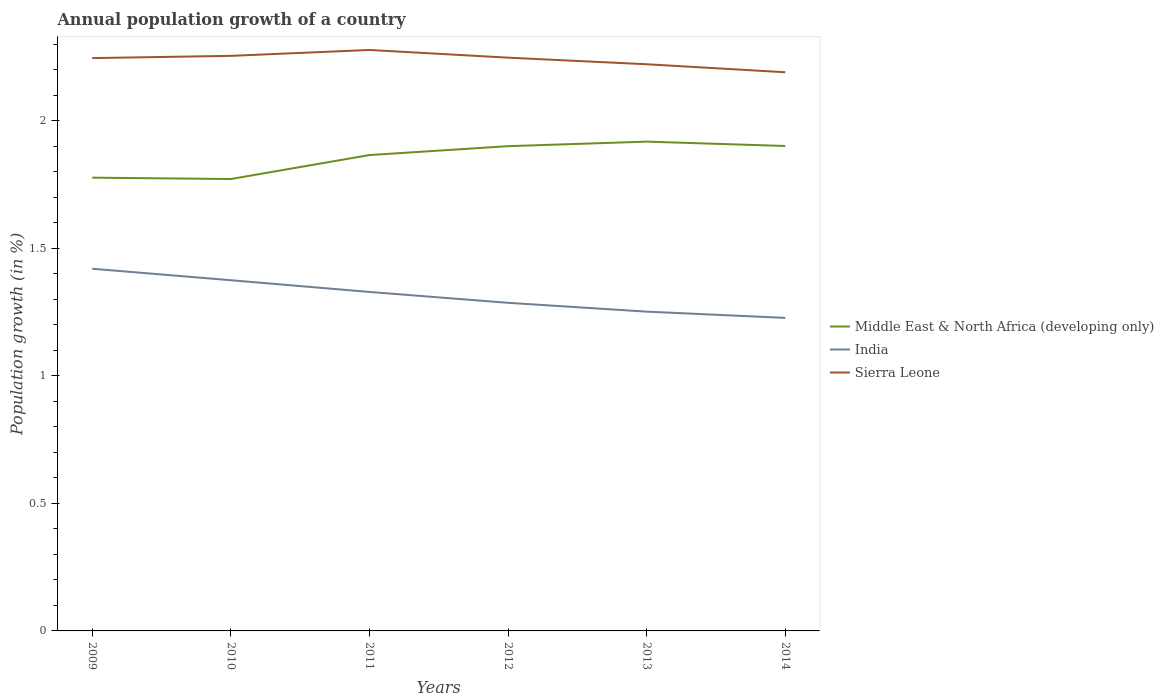Does the line corresponding to Sierra Leone intersect with the line corresponding to Middle East & North Africa (developing only)?
Offer a terse response. No. Is the number of lines equal to the number of legend labels?
Ensure brevity in your answer.  Yes. Across all years, what is the maximum annual population growth in Middle East & North Africa (developing only)?
Provide a short and direct response. 1.77. What is the total annual population growth in Sierra Leone in the graph?
Your answer should be compact. 0.02. What is the difference between the highest and the second highest annual population growth in Middle East & North Africa (developing only)?
Your answer should be compact. 0.15. Does the graph contain any zero values?
Provide a short and direct response. No. Does the graph contain grids?
Keep it short and to the point. No. Where does the legend appear in the graph?
Keep it short and to the point. Center right. How many legend labels are there?
Ensure brevity in your answer.  3. What is the title of the graph?
Provide a short and direct response. Annual population growth of a country. What is the label or title of the Y-axis?
Your response must be concise. Population growth (in %). What is the Population growth (in %) of Middle East & North Africa (developing only) in 2009?
Offer a very short reply. 1.78. What is the Population growth (in %) of India in 2009?
Your answer should be compact. 1.42. What is the Population growth (in %) in Sierra Leone in 2009?
Keep it short and to the point. 2.24. What is the Population growth (in %) in Middle East & North Africa (developing only) in 2010?
Give a very brief answer. 1.77. What is the Population growth (in %) in India in 2010?
Offer a terse response. 1.37. What is the Population growth (in %) of Sierra Leone in 2010?
Make the answer very short. 2.25. What is the Population growth (in %) in Middle East & North Africa (developing only) in 2011?
Offer a terse response. 1.86. What is the Population growth (in %) of India in 2011?
Keep it short and to the point. 1.33. What is the Population growth (in %) in Sierra Leone in 2011?
Keep it short and to the point. 2.28. What is the Population growth (in %) in Middle East & North Africa (developing only) in 2012?
Offer a terse response. 1.9. What is the Population growth (in %) in India in 2012?
Provide a succinct answer. 1.29. What is the Population growth (in %) in Sierra Leone in 2012?
Make the answer very short. 2.25. What is the Population growth (in %) of Middle East & North Africa (developing only) in 2013?
Your answer should be very brief. 1.92. What is the Population growth (in %) in India in 2013?
Make the answer very short. 1.25. What is the Population growth (in %) in Sierra Leone in 2013?
Provide a short and direct response. 2.22. What is the Population growth (in %) in Middle East & North Africa (developing only) in 2014?
Your response must be concise. 1.9. What is the Population growth (in %) in India in 2014?
Give a very brief answer. 1.23. What is the Population growth (in %) in Sierra Leone in 2014?
Provide a short and direct response. 2.19. Across all years, what is the maximum Population growth (in %) in Middle East & North Africa (developing only)?
Your answer should be compact. 1.92. Across all years, what is the maximum Population growth (in %) in India?
Your response must be concise. 1.42. Across all years, what is the maximum Population growth (in %) in Sierra Leone?
Make the answer very short. 2.28. Across all years, what is the minimum Population growth (in %) in Middle East & North Africa (developing only)?
Your answer should be very brief. 1.77. Across all years, what is the minimum Population growth (in %) in India?
Provide a succinct answer. 1.23. Across all years, what is the minimum Population growth (in %) in Sierra Leone?
Make the answer very short. 2.19. What is the total Population growth (in %) in Middle East & North Africa (developing only) in the graph?
Your answer should be compact. 11.13. What is the total Population growth (in %) in India in the graph?
Offer a very short reply. 7.89. What is the total Population growth (in %) in Sierra Leone in the graph?
Ensure brevity in your answer.  13.43. What is the difference between the Population growth (in %) of Middle East & North Africa (developing only) in 2009 and that in 2010?
Your answer should be very brief. 0.01. What is the difference between the Population growth (in %) in India in 2009 and that in 2010?
Provide a short and direct response. 0.04. What is the difference between the Population growth (in %) in Sierra Leone in 2009 and that in 2010?
Offer a very short reply. -0.01. What is the difference between the Population growth (in %) in Middle East & North Africa (developing only) in 2009 and that in 2011?
Keep it short and to the point. -0.09. What is the difference between the Population growth (in %) of India in 2009 and that in 2011?
Your answer should be very brief. 0.09. What is the difference between the Population growth (in %) of Sierra Leone in 2009 and that in 2011?
Keep it short and to the point. -0.03. What is the difference between the Population growth (in %) in Middle East & North Africa (developing only) in 2009 and that in 2012?
Keep it short and to the point. -0.12. What is the difference between the Population growth (in %) in India in 2009 and that in 2012?
Keep it short and to the point. 0.13. What is the difference between the Population growth (in %) in Sierra Leone in 2009 and that in 2012?
Your answer should be compact. -0. What is the difference between the Population growth (in %) of Middle East & North Africa (developing only) in 2009 and that in 2013?
Make the answer very short. -0.14. What is the difference between the Population growth (in %) of India in 2009 and that in 2013?
Offer a very short reply. 0.17. What is the difference between the Population growth (in %) of Sierra Leone in 2009 and that in 2013?
Offer a very short reply. 0.02. What is the difference between the Population growth (in %) of Middle East & North Africa (developing only) in 2009 and that in 2014?
Provide a short and direct response. -0.12. What is the difference between the Population growth (in %) of India in 2009 and that in 2014?
Make the answer very short. 0.19. What is the difference between the Population growth (in %) in Sierra Leone in 2009 and that in 2014?
Provide a succinct answer. 0.06. What is the difference between the Population growth (in %) of Middle East & North Africa (developing only) in 2010 and that in 2011?
Your answer should be very brief. -0.09. What is the difference between the Population growth (in %) of India in 2010 and that in 2011?
Ensure brevity in your answer.  0.05. What is the difference between the Population growth (in %) in Sierra Leone in 2010 and that in 2011?
Provide a short and direct response. -0.02. What is the difference between the Population growth (in %) of Middle East & North Africa (developing only) in 2010 and that in 2012?
Ensure brevity in your answer.  -0.13. What is the difference between the Population growth (in %) of India in 2010 and that in 2012?
Offer a terse response. 0.09. What is the difference between the Population growth (in %) in Sierra Leone in 2010 and that in 2012?
Make the answer very short. 0.01. What is the difference between the Population growth (in %) of Middle East & North Africa (developing only) in 2010 and that in 2013?
Keep it short and to the point. -0.15. What is the difference between the Population growth (in %) in India in 2010 and that in 2013?
Provide a short and direct response. 0.12. What is the difference between the Population growth (in %) of Sierra Leone in 2010 and that in 2013?
Offer a very short reply. 0.03. What is the difference between the Population growth (in %) in Middle East & North Africa (developing only) in 2010 and that in 2014?
Make the answer very short. -0.13. What is the difference between the Population growth (in %) of India in 2010 and that in 2014?
Ensure brevity in your answer.  0.15. What is the difference between the Population growth (in %) in Sierra Leone in 2010 and that in 2014?
Provide a succinct answer. 0.06. What is the difference between the Population growth (in %) in Middle East & North Africa (developing only) in 2011 and that in 2012?
Your answer should be compact. -0.03. What is the difference between the Population growth (in %) of India in 2011 and that in 2012?
Provide a short and direct response. 0.04. What is the difference between the Population growth (in %) in Sierra Leone in 2011 and that in 2012?
Make the answer very short. 0.03. What is the difference between the Population growth (in %) in Middle East & North Africa (developing only) in 2011 and that in 2013?
Offer a terse response. -0.05. What is the difference between the Population growth (in %) in India in 2011 and that in 2013?
Your answer should be compact. 0.08. What is the difference between the Population growth (in %) of Sierra Leone in 2011 and that in 2013?
Offer a terse response. 0.06. What is the difference between the Population growth (in %) of Middle East & North Africa (developing only) in 2011 and that in 2014?
Offer a very short reply. -0.04. What is the difference between the Population growth (in %) of India in 2011 and that in 2014?
Your answer should be very brief. 0.1. What is the difference between the Population growth (in %) in Sierra Leone in 2011 and that in 2014?
Your answer should be very brief. 0.09. What is the difference between the Population growth (in %) of Middle East & North Africa (developing only) in 2012 and that in 2013?
Provide a short and direct response. -0.02. What is the difference between the Population growth (in %) of India in 2012 and that in 2013?
Ensure brevity in your answer.  0.03. What is the difference between the Population growth (in %) in Sierra Leone in 2012 and that in 2013?
Provide a succinct answer. 0.03. What is the difference between the Population growth (in %) of Middle East & North Africa (developing only) in 2012 and that in 2014?
Provide a succinct answer. -0. What is the difference between the Population growth (in %) of India in 2012 and that in 2014?
Offer a terse response. 0.06. What is the difference between the Population growth (in %) in Sierra Leone in 2012 and that in 2014?
Keep it short and to the point. 0.06. What is the difference between the Population growth (in %) of Middle East & North Africa (developing only) in 2013 and that in 2014?
Your answer should be very brief. 0.02. What is the difference between the Population growth (in %) of India in 2013 and that in 2014?
Offer a very short reply. 0.02. What is the difference between the Population growth (in %) of Sierra Leone in 2013 and that in 2014?
Offer a terse response. 0.03. What is the difference between the Population growth (in %) in Middle East & North Africa (developing only) in 2009 and the Population growth (in %) in India in 2010?
Keep it short and to the point. 0.4. What is the difference between the Population growth (in %) of Middle East & North Africa (developing only) in 2009 and the Population growth (in %) of Sierra Leone in 2010?
Give a very brief answer. -0.48. What is the difference between the Population growth (in %) in India in 2009 and the Population growth (in %) in Sierra Leone in 2010?
Provide a short and direct response. -0.83. What is the difference between the Population growth (in %) in Middle East & North Africa (developing only) in 2009 and the Population growth (in %) in India in 2011?
Your response must be concise. 0.45. What is the difference between the Population growth (in %) in Middle East & North Africa (developing only) in 2009 and the Population growth (in %) in Sierra Leone in 2011?
Provide a succinct answer. -0.5. What is the difference between the Population growth (in %) of India in 2009 and the Population growth (in %) of Sierra Leone in 2011?
Ensure brevity in your answer.  -0.86. What is the difference between the Population growth (in %) in Middle East & North Africa (developing only) in 2009 and the Population growth (in %) in India in 2012?
Offer a very short reply. 0.49. What is the difference between the Population growth (in %) of Middle East & North Africa (developing only) in 2009 and the Population growth (in %) of Sierra Leone in 2012?
Keep it short and to the point. -0.47. What is the difference between the Population growth (in %) in India in 2009 and the Population growth (in %) in Sierra Leone in 2012?
Your answer should be compact. -0.83. What is the difference between the Population growth (in %) in Middle East & North Africa (developing only) in 2009 and the Population growth (in %) in India in 2013?
Your answer should be compact. 0.53. What is the difference between the Population growth (in %) of Middle East & North Africa (developing only) in 2009 and the Population growth (in %) of Sierra Leone in 2013?
Offer a very short reply. -0.44. What is the difference between the Population growth (in %) of India in 2009 and the Population growth (in %) of Sierra Leone in 2013?
Provide a succinct answer. -0.8. What is the difference between the Population growth (in %) of Middle East & North Africa (developing only) in 2009 and the Population growth (in %) of India in 2014?
Keep it short and to the point. 0.55. What is the difference between the Population growth (in %) of Middle East & North Africa (developing only) in 2009 and the Population growth (in %) of Sierra Leone in 2014?
Offer a terse response. -0.41. What is the difference between the Population growth (in %) in India in 2009 and the Population growth (in %) in Sierra Leone in 2014?
Keep it short and to the point. -0.77. What is the difference between the Population growth (in %) of Middle East & North Africa (developing only) in 2010 and the Population growth (in %) of India in 2011?
Offer a terse response. 0.44. What is the difference between the Population growth (in %) in Middle East & North Africa (developing only) in 2010 and the Population growth (in %) in Sierra Leone in 2011?
Your response must be concise. -0.51. What is the difference between the Population growth (in %) in India in 2010 and the Population growth (in %) in Sierra Leone in 2011?
Provide a short and direct response. -0.9. What is the difference between the Population growth (in %) in Middle East & North Africa (developing only) in 2010 and the Population growth (in %) in India in 2012?
Offer a terse response. 0.49. What is the difference between the Population growth (in %) in Middle East & North Africa (developing only) in 2010 and the Population growth (in %) in Sierra Leone in 2012?
Offer a terse response. -0.48. What is the difference between the Population growth (in %) in India in 2010 and the Population growth (in %) in Sierra Leone in 2012?
Keep it short and to the point. -0.87. What is the difference between the Population growth (in %) of Middle East & North Africa (developing only) in 2010 and the Population growth (in %) of India in 2013?
Your response must be concise. 0.52. What is the difference between the Population growth (in %) of Middle East & North Africa (developing only) in 2010 and the Population growth (in %) of Sierra Leone in 2013?
Your answer should be compact. -0.45. What is the difference between the Population growth (in %) of India in 2010 and the Population growth (in %) of Sierra Leone in 2013?
Provide a succinct answer. -0.85. What is the difference between the Population growth (in %) of Middle East & North Africa (developing only) in 2010 and the Population growth (in %) of India in 2014?
Keep it short and to the point. 0.54. What is the difference between the Population growth (in %) of Middle East & North Africa (developing only) in 2010 and the Population growth (in %) of Sierra Leone in 2014?
Your answer should be very brief. -0.42. What is the difference between the Population growth (in %) in India in 2010 and the Population growth (in %) in Sierra Leone in 2014?
Make the answer very short. -0.81. What is the difference between the Population growth (in %) in Middle East & North Africa (developing only) in 2011 and the Population growth (in %) in India in 2012?
Make the answer very short. 0.58. What is the difference between the Population growth (in %) in Middle East & North Africa (developing only) in 2011 and the Population growth (in %) in Sierra Leone in 2012?
Provide a succinct answer. -0.38. What is the difference between the Population growth (in %) in India in 2011 and the Population growth (in %) in Sierra Leone in 2012?
Give a very brief answer. -0.92. What is the difference between the Population growth (in %) of Middle East & North Africa (developing only) in 2011 and the Population growth (in %) of India in 2013?
Give a very brief answer. 0.61. What is the difference between the Population growth (in %) of Middle East & North Africa (developing only) in 2011 and the Population growth (in %) of Sierra Leone in 2013?
Offer a terse response. -0.36. What is the difference between the Population growth (in %) of India in 2011 and the Population growth (in %) of Sierra Leone in 2013?
Offer a very short reply. -0.89. What is the difference between the Population growth (in %) in Middle East & North Africa (developing only) in 2011 and the Population growth (in %) in India in 2014?
Offer a terse response. 0.64. What is the difference between the Population growth (in %) in Middle East & North Africa (developing only) in 2011 and the Population growth (in %) in Sierra Leone in 2014?
Your answer should be compact. -0.32. What is the difference between the Population growth (in %) in India in 2011 and the Population growth (in %) in Sierra Leone in 2014?
Make the answer very short. -0.86. What is the difference between the Population growth (in %) in Middle East & North Africa (developing only) in 2012 and the Population growth (in %) in India in 2013?
Ensure brevity in your answer.  0.65. What is the difference between the Population growth (in %) of Middle East & North Africa (developing only) in 2012 and the Population growth (in %) of Sierra Leone in 2013?
Provide a succinct answer. -0.32. What is the difference between the Population growth (in %) in India in 2012 and the Population growth (in %) in Sierra Leone in 2013?
Keep it short and to the point. -0.93. What is the difference between the Population growth (in %) in Middle East & North Africa (developing only) in 2012 and the Population growth (in %) in India in 2014?
Keep it short and to the point. 0.67. What is the difference between the Population growth (in %) of Middle East & North Africa (developing only) in 2012 and the Population growth (in %) of Sierra Leone in 2014?
Keep it short and to the point. -0.29. What is the difference between the Population growth (in %) in India in 2012 and the Population growth (in %) in Sierra Leone in 2014?
Keep it short and to the point. -0.9. What is the difference between the Population growth (in %) of Middle East & North Africa (developing only) in 2013 and the Population growth (in %) of India in 2014?
Your answer should be compact. 0.69. What is the difference between the Population growth (in %) in Middle East & North Africa (developing only) in 2013 and the Population growth (in %) in Sierra Leone in 2014?
Ensure brevity in your answer.  -0.27. What is the difference between the Population growth (in %) of India in 2013 and the Population growth (in %) of Sierra Leone in 2014?
Your response must be concise. -0.94. What is the average Population growth (in %) in Middle East & North Africa (developing only) per year?
Offer a very short reply. 1.85. What is the average Population growth (in %) in India per year?
Offer a terse response. 1.31. What is the average Population growth (in %) in Sierra Leone per year?
Your answer should be very brief. 2.24. In the year 2009, what is the difference between the Population growth (in %) of Middle East & North Africa (developing only) and Population growth (in %) of India?
Ensure brevity in your answer.  0.36. In the year 2009, what is the difference between the Population growth (in %) of Middle East & North Africa (developing only) and Population growth (in %) of Sierra Leone?
Keep it short and to the point. -0.47. In the year 2009, what is the difference between the Population growth (in %) in India and Population growth (in %) in Sierra Leone?
Make the answer very short. -0.83. In the year 2010, what is the difference between the Population growth (in %) of Middle East & North Africa (developing only) and Population growth (in %) of India?
Provide a short and direct response. 0.4. In the year 2010, what is the difference between the Population growth (in %) of Middle East & North Africa (developing only) and Population growth (in %) of Sierra Leone?
Your response must be concise. -0.48. In the year 2010, what is the difference between the Population growth (in %) in India and Population growth (in %) in Sierra Leone?
Your answer should be very brief. -0.88. In the year 2011, what is the difference between the Population growth (in %) in Middle East & North Africa (developing only) and Population growth (in %) in India?
Your answer should be very brief. 0.54. In the year 2011, what is the difference between the Population growth (in %) of Middle East & North Africa (developing only) and Population growth (in %) of Sierra Leone?
Your answer should be compact. -0.41. In the year 2011, what is the difference between the Population growth (in %) in India and Population growth (in %) in Sierra Leone?
Your answer should be compact. -0.95. In the year 2012, what is the difference between the Population growth (in %) in Middle East & North Africa (developing only) and Population growth (in %) in India?
Give a very brief answer. 0.61. In the year 2012, what is the difference between the Population growth (in %) of Middle East & North Africa (developing only) and Population growth (in %) of Sierra Leone?
Make the answer very short. -0.35. In the year 2012, what is the difference between the Population growth (in %) in India and Population growth (in %) in Sierra Leone?
Your answer should be very brief. -0.96. In the year 2013, what is the difference between the Population growth (in %) of Middle East & North Africa (developing only) and Population growth (in %) of India?
Your response must be concise. 0.67. In the year 2013, what is the difference between the Population growth (in %) of Middle East & North Africa (developing only) and Population growth (in %) of Sierra Leone?
Ensure brevity in your answer.  -0.3. In the year 2013, what is the difference between the Population growth (in %) in India and Population growth (in %) in Sierra Leone?
Give a very brief answer. -0.97. In the year 2014, what is the difference between the Population growth (in %) in Middle East & North Africa (developing only) and Population growth (in %) in India?
Offer a terse response. 0.67. In the year 2014, what is the difference between the Population growth (in %) in Middle East & North Africa (developing only) and Population growth (in %) in Sierra Leone?
Your answer should be very brief. -0.29. In the year 2014, what is the difference between the Population growth (in %) in India and Population growth (in %) in Sierra Leone?
Provide a succinct answer. -0.96. What is the ratio of the Population growth (in %) of India in 2009 to that in 2010?
Provide a succinct answer. 1.03. What is the ratio of the Population growth (in %) in Sierra Leone in 2009 to that in 2010?
Your answer should be very brief. 1. What is the ratio of the Population growth (in %) in Middle East & North Africa (developing only) in 2009 to that in 2011?
Ensure brevity in your answer.  0.95. What is the ratio of the Population growth (in %) in India in 2009 to that in 2011?
Your answer should be very brief. 1.07. What is the ratio of the Population growth (in %) of Sierra Leone in 2009 to that in 2011?
Offer a very short reply. 0.99. What is the ratio of the Population growth (in %) in Middle East & North Africa (developing only) in 2009 to that in 2012?
Ensure brevity in your answer.  0.94. What is the ratio of the Population growth (in %) in India in 2009 to that in 2012?
Give a very brief answer. 1.1. What is the ratio of the Population growth (in %) of Middle East & North Africa (developing only) in 2009 to that in 2013?
Your response must be concise. 0.93. What is the ratio of the Population growth (in %) in India in 2009 to that in 2013?
Keep it short and to the point. 1.13. What is the ratio of the Population growth (in %) in Sierra Leone in 2009 to that in 2013?
Offer a very short reply. 1.01. What is the ratio of the Population growth (in %) of Middle East & North Africa (developing only) in 2009 to that in 2014?
Keep it short and to the point. 0.93. What is the ratio of the Population growth (in %) in India in 2009 to that in 2014?
Give a very brief answer. 1.16. What is the ratio of the Population growth (in %) in Sierra Leone in 2009 to that in 2014?
Keep it short and to the point. 1.03. What is the ratio of the Population growth (in %) of Middle East & North Africa (developing only) in 2010 to that in 2011?
Provide a succinct answer. 0.95. What is the ratio of the Population growth (in %) in India in 2010 to that in 2011?
Give a very brief answer. 1.03. What is the ratio of the Population growth (in %) in Sierra Leone in 2010 to that in 2011?
Give a very brief answer. 0.99. What is the ratio of the Population growth (in %) in Middle East & North Africa (developing only) in 2010 to that in 2012?
Your answer should be very brief. 0.93. What is the ratio of the Population growth (in %) of India in 2010 to that in 2012?
Your answer should be very brief. 1.07. What is the ratio of the Population growth (in %) in Sierra Leone in 2010 to that in 2012?
Keep it short and to the point. 1. What is the ratio of the Population growth (in %) in Middle East & North Africa (developing only) in 2010 to that in 2013?
Ensure brevity in your answer.  0.92. What is the ratio of the Population growth (in %) of India in 2010 to that in 2013?
Keep it short and to the point. 1.1. What is the ratio of the Population growth (in %) of Sierra Leone in 2010 to that in 2013?
Ensure brevity in your answer.  1.01. What is the ratio of the Population growth (in %) in Middle East & North Africa (developing only) in 2010 to that in 2014?
Offer a very short reply. 0.93. What is the ratio of the Population growth (in %) of India in 2010 to that in 2014?
Provide a short and direct response. 1.12. What is the ratio of the Population growth (in %) in Sierra Leone in 2010 to that in 2014?
Provide a short and direct response. 1.03. What is the ratio of the Population growth (in %) in Middle East & North Africa (developing only) in 2011 to that in 2012?
Provide a short and direct response. 0.98. What is the ratio of the Population growth (in %) of India in 2011 to that in 2012?
Give a very brief answer. 1.03. What is the ratio of the Population growth (in %) in Sierra Leone in 2011 to that in 2012?
Offer a terse response. 1.01. What is the ratio of the Population growth (in %) of Middle East & North Africa (developing only) in 2011 to that in 2013?
Offer a terse response. 0.97. What is the ratio of the Population growth (in %) in India in 2011 to that in 2013?
Provide a short and direct response. 1.06. What is the ratio of the Population growth (in %) of Sierra Leone in 2011 to that in 2013?
Give a very brief answer. 1.03. What is the ratio of the Population growth (in %) of Middle East & North Africa (developing only) in 2011 to that in 2014?
Make the answer very short. 0.98. What is the ratio of the Population growth (in %) in India in 2011 to that in 2014?
Offer a terse response. 1.08. What is the ratio of the Population growth (in %) in Sierra Leone in 2011 to that in 2014?
Ensure brevity in your answer.  1.04. What is the ratio of the Population growth (in %) in India in 2012 to that in 2013?
Provide a short and direct response. 1.03. What is the ratio of the Population growth (in %) of Sierra Leone in 2012 to that in 2013?
Your answer should be compact. 1.01. What is the ratio of the Population growth (in %) of Middle East & North Africa (developing only) in 2012 to that in 2014?
Ensure brevity in your answer.  1. What is the ratio of the Population growth (in %) of India in 2012 to that in 2014?
Provide a short and direct response. 1.05. What is the ratio of the Population growth (in %) in Sierra Leone in 2012 to that in 2014?
Your response must be concise. 1.03. What is the ratio of the Population growth (in %) of Middle East & North Africa (developing only) in 2013 to that in 2014?
Your response must be concise. 1.01. What is the ratio of the Population growth (in %) in India in 2013 to that in 2014?
Give a very brief answer. 1.02. What is the ratio of the Population growth (in %) of Sierra Leone in 2013 to that in 2014?
Give a very brief answer. 1.01. What is the difference between the highest and the second highest Population growth (in %) of Middle East & North Africa (developing only)?
Offer a very short reply. 0.02. What is the difference between the highest and the second highest Population growth (in %) of India?
Offer a very short reply. 0.04. What is the difference between the highest and the second highest Population growth (in %) of Sierra Leone?
Offer a terse response. 0.02. What is the difference between the highest and the lowest Population growth (in %) in Middle East & North Africa (developing only)?
Your response must be concise. 0.15. What is the difference between the highest and the lowest Population growth (in %) in India?
Your response must be concise. 0.19. What is the difference between the highest and the lowest Population growth (in %) of Sierra Leone?
Give a very brief answer. 0.09. 